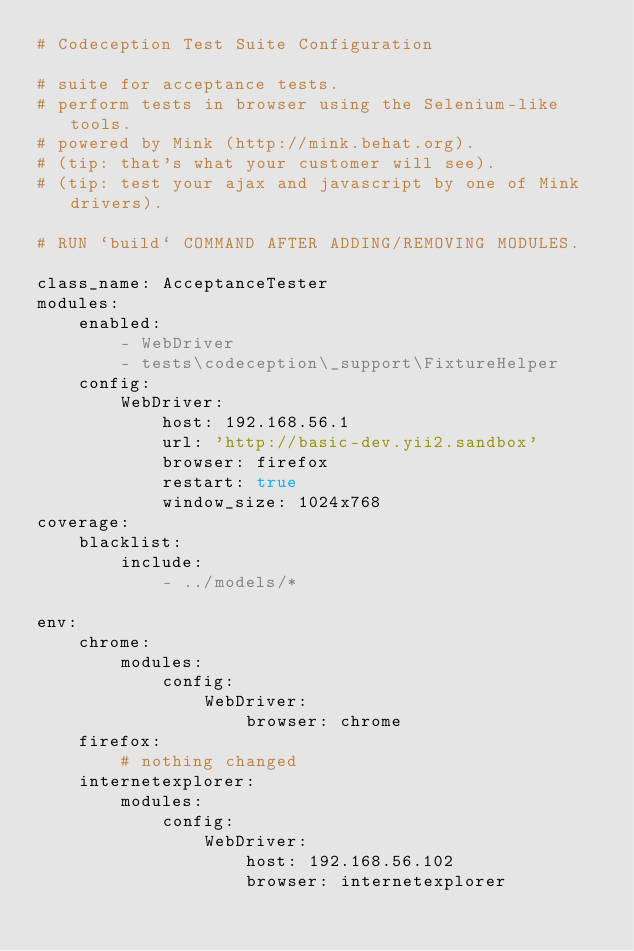<code> <loc_0><loc_0><loc_500><loc_500><_YAML_># Codeception Test Suite Configuration

# suite for acceptance tests.
# perform tests in browser using the Selenium-like tools.
# powered by Mink (http://mink.behat.org).
# (tip: that's what your customer will see).
# (tip: test your ajax and javascript by one of Mink drivers).

# RUN `build` COMMAND AFTER ADDING/REMOVING MODULES.

class_name: AcceptanceTester
modules:
    enabled:
        - WebDriver
        - tests\codeception\_support\FixtureHelper
    config:
        WebDriver:
            host: 192.168.56.1
            url: 'http://basic-dev.yii2.sandbox'
            browser: firefox
            restart: true
            window_size: 1024x768
coverage:
    blacklist:
        include:
            - ../models/*

env:
    chrome:
        modules:
            config:
                WebDriver:
                    browser: chrome
    firefox:
        # nothing changed
    internetexplorer:
        modules:
            config:
                WebDriver:
                    host: 192.168.56.102
                    browser: internetexplorer
</code> 